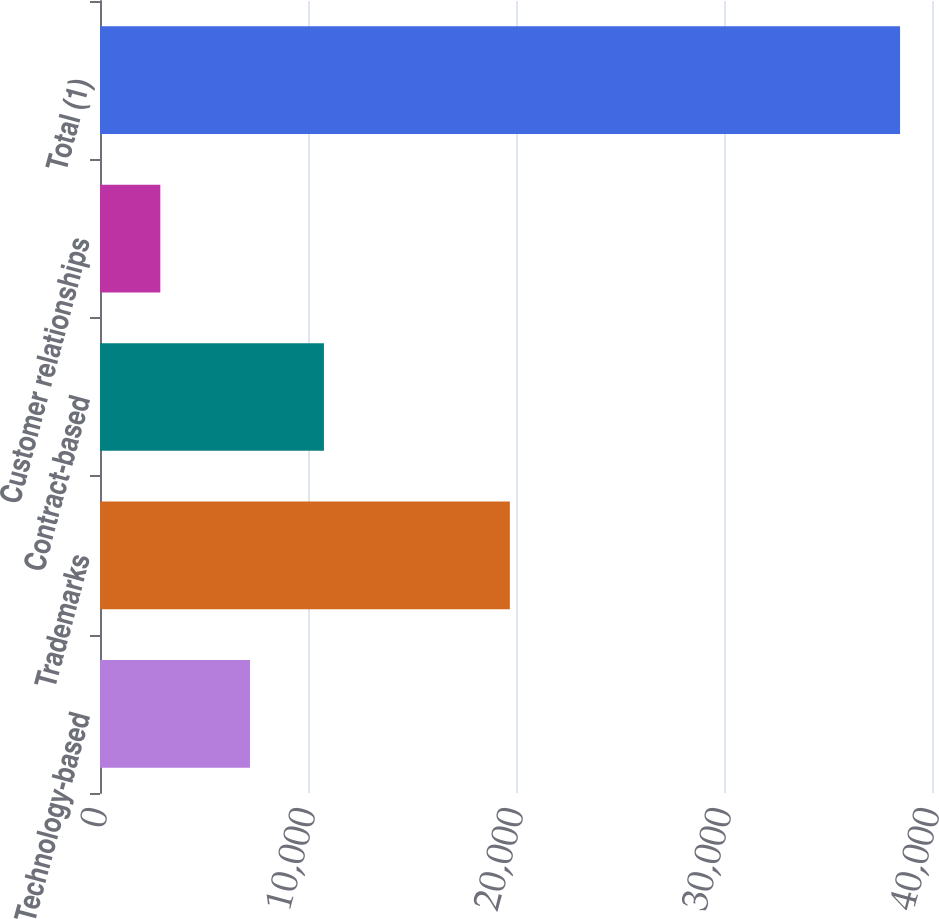Convert chart to OTSL. <chart><loc_0><loc_0><loc_500><loc_500><bar_chart><fcel>Technology-based<fcel>Trademarks<fcel>Contract-based<fcel>Customer relationships<fcel>Total (1)<nl><fcel>7210<fcel>19704<fcel>10766.4<fcel>2900<fcel>38464<nl></chart> 